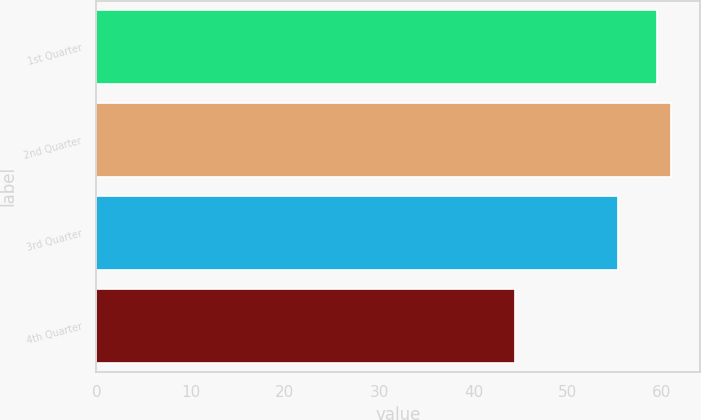Convert chart to OTSL. <chart><loc_0><loc_0><loc_500><loc_500><bar_chart><fcel>1st Quarter<fcel>2nd Quarter<fcel>3rd Quarter<fcel>4th Quarter<nl><fcel>59.46<fcel>60.99<fcel>55.34<fcel>44.37<nl></chart> 